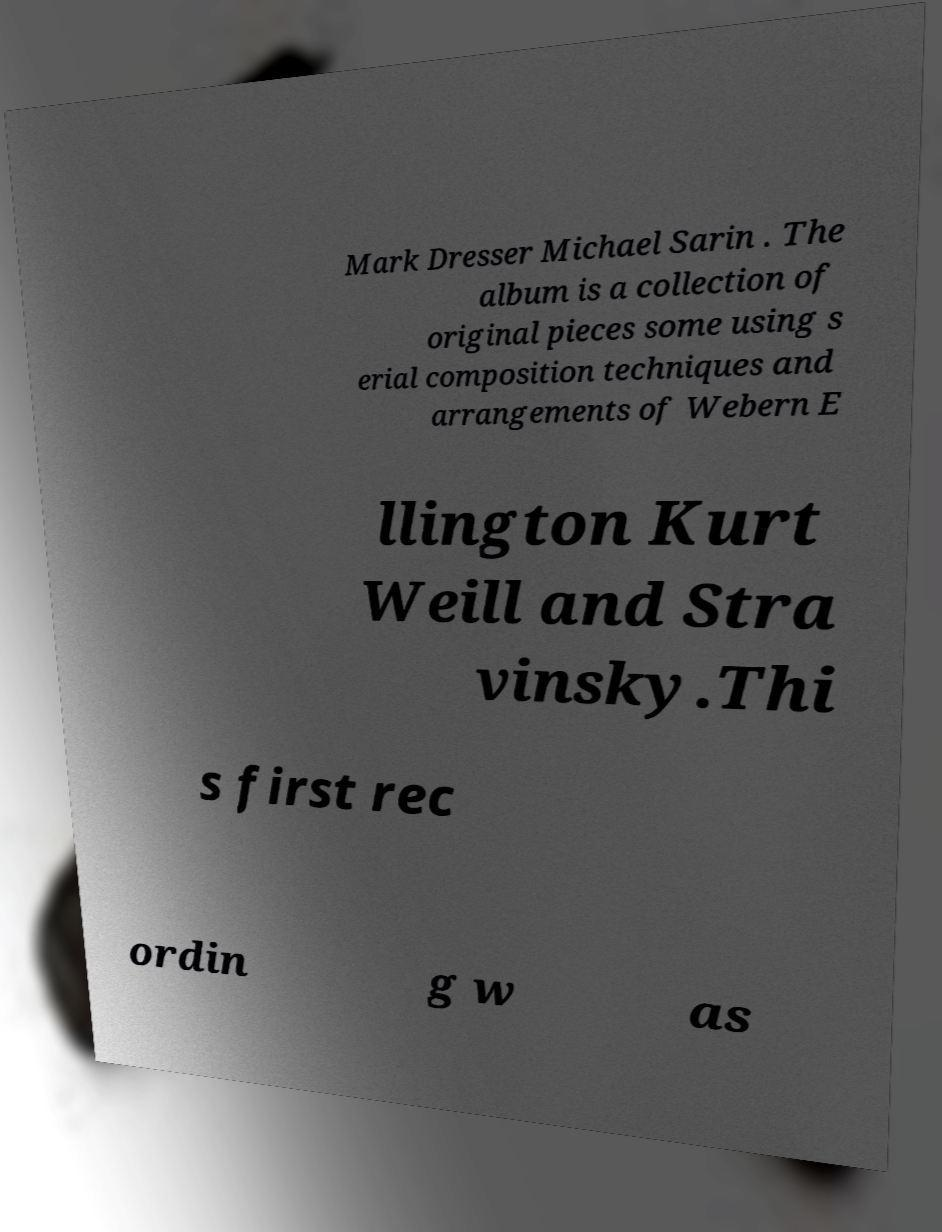What messages or text are displayed in this image? I need them in a readable, typed format. Mark Dresser Michael Sarin . The album is a collection of original pieces some using s erial composition techniques and arrangements of Webern E llington Kurt Weill and Stra vinsky.Thi s first rec ordin g w as 